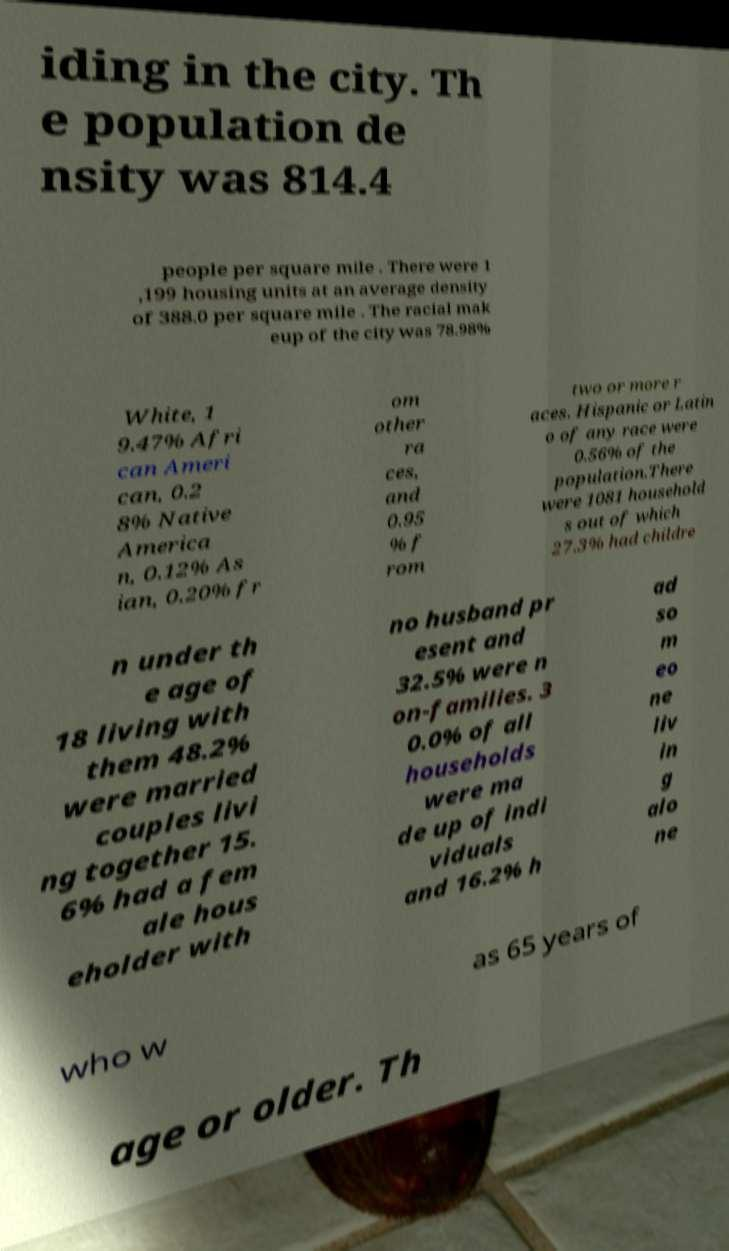What messages or text are displayed in this image? I need them in a readable, typed format. iding in the city. Th e population de nsity was 814.4 people per square mile . There were 1 ,199 housing units at an average density of 388.0 per square mile . The racial mak eup of the city was 78.98% White, 1 9.47% Afri can Ameri can, 0.2 8% Native America n, 0.12% As ian, 0.20% fr om other ra ces, and 0.95 % f rom two or more r aces. Hispanic or Latin o of any race were 0.56% of the population.There were 1081 household s out of which 27.3% had childre n under th e age of 18 living with them 48.2% were married couples livi ng together 15. 6% had a fem ale hous eholder with no husband pr esent and 32.5% were n on-families. 3 0.0% of all households were ma de up of indi viduals and 16.2% h ad so m eo ne liv in g alo ne who w as 65 years of age or older. Th 